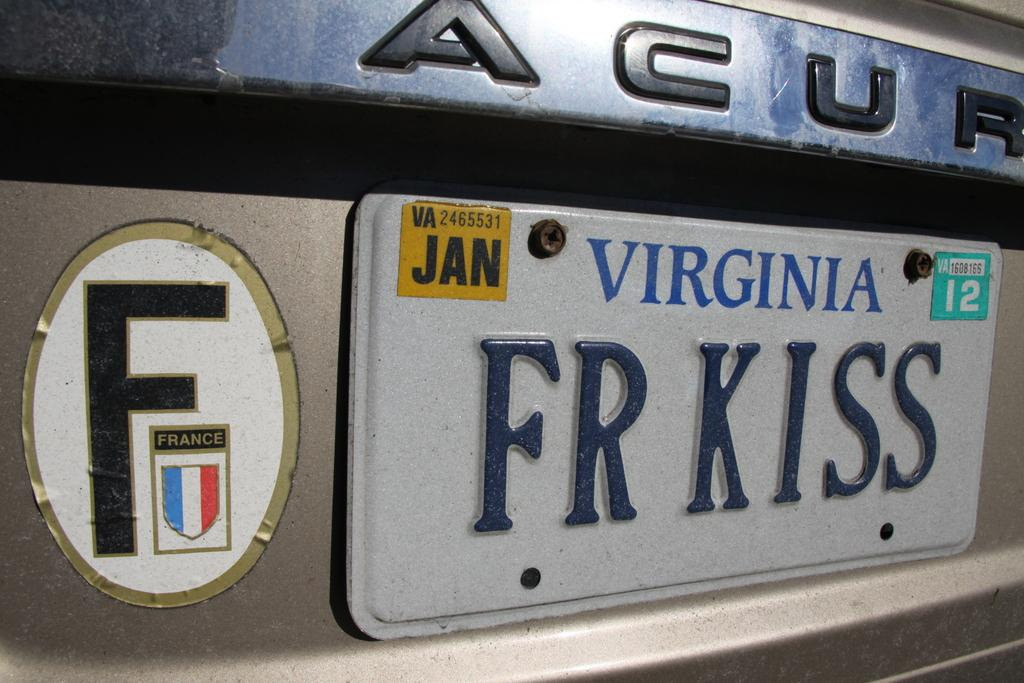<image>
Provide a brief description of the given image. The back bumper of an acura with a virginia state license plate on it. 